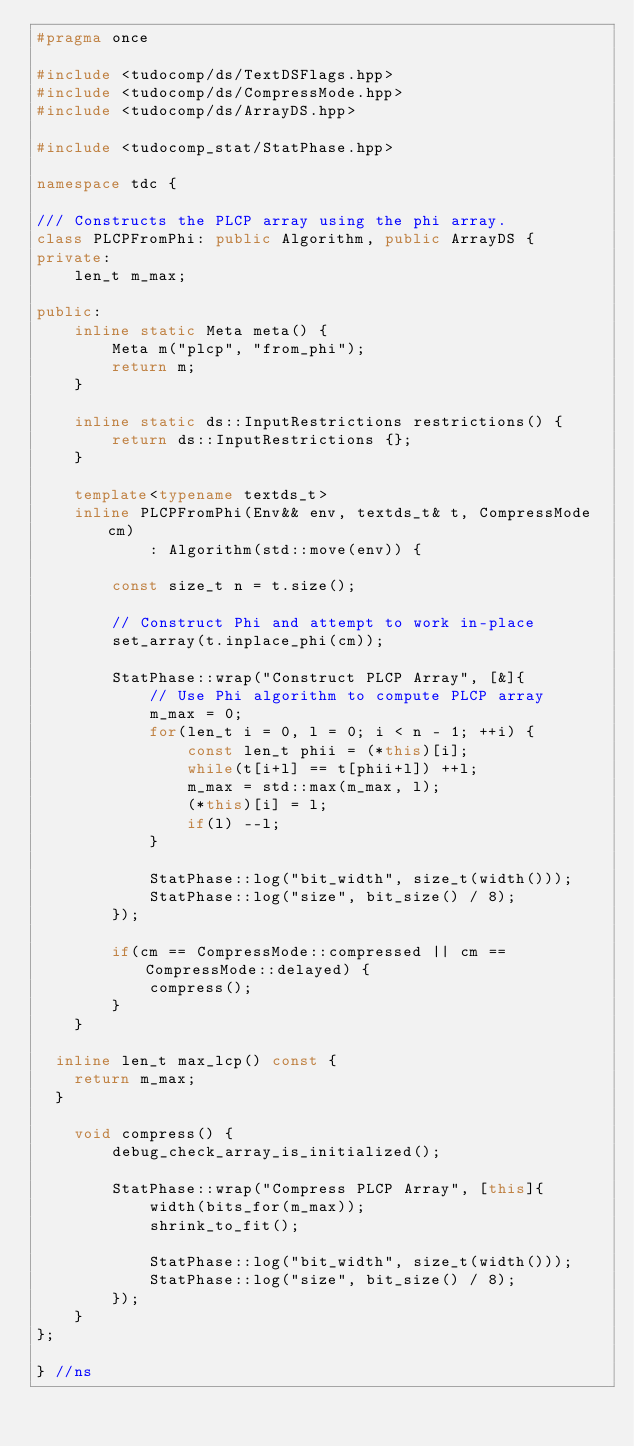Convert code to text. <code><loc_0><loc_0><loc_500><loc_500><_C++_>#pragma once

#include <tudocomp/ds/TextDSFlags.hpp>
#include <tudocomp/ds/CompressMode.hpp>
#include <tudocomp/ds/ArrayDS.hpp>

#include <tudocomp_stat/StatPhase.hpp>

namespace tdc {

/// Constructs the PLCP array using the phi array.
class PLCPFromPhi: public Algorithm, public ArrayDS {
private:
    len_t m_max;

public:
    inline static Meta meta() {
        Meta m("plcp", "from_phi");
        return m;
    }

    inline static ds::InputRestrictions restrictions() {
        return ds::InputRestrictions {};
    }

    template<typename textds_t>
    inline PLCPFromPhi(Env&& env, textds_t& t, CompressMode cm)
            : Algorithm(std::move(env)) {

        const size_t n = t.size();

        // Construct Phi and attempt to work in-place
        set_array(t.inplace_phi(cm));

        StatPhase::wrap("Construct PLCP Array", [&]{
            // Use Phi algorithm to compute PLCP array
            m_max = 0;
            for(len_t i = 0, l = 0; i < n - 1; ++i) {
                const len_t phii = (*this)[i];
                while(t[i+l] == t[phii+l]) ++l;
                m_max = std::max(m_max, l);
                (*this)[i] = l;
                if(l) --l;
            }

            StatPhase::log("bit_width", size_t(width()));
            StatPhase::log("size", bit_size() / 8);
        });

        if(cm == CompressMode::compressed || cm == CompressMode::delayed) {
            compress();
        }
    }

	inline len_t max_lcp() const {
		return m_max;
	}

    void compress() {
        debug_check_array_is_initialized();

        StatPhase::wrap("Compress PLCP Array", [this]{
            width(bits_for(m_max));
            shrink_to_fit();

            StatPhase::log("bit_width", size_t(width()));
            StatPhase::log("size", bit_size() / 8);
        });
    }
};

} //ns
</code> 